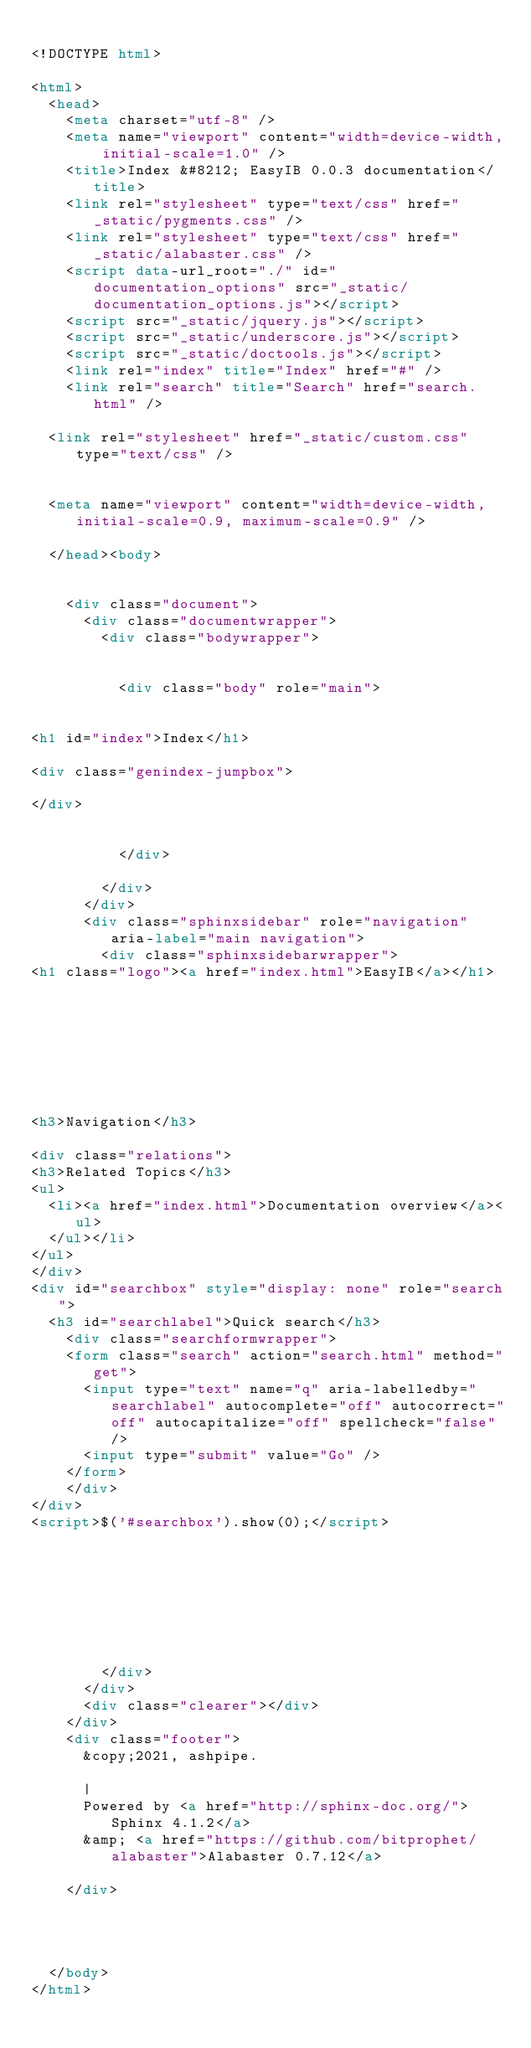<code> <loc_0><loc_0><loc_500><loc_500><_HTML_>
<!DOCTYPE html>

<html>
  <head>
    <meta charset="utf-8" />
    <meta name="viewport" content="width=device-width, initial-scale=1.0" />
    <title>Index &#8212; EasyIB 0.0.3 documentation</title>
    <link rel="stylesheet" type="text/css" href="_static/pygments.css" />
    <link rel="stylesheet" type="text/css" href="_static/alabaster.css" />
    <script data-url_root="./" id="documentation_options" src="_static/documentation_options.js"></script>
    <script src="_static/jquery.js"></script>
    <script src="_static/underscore.js"></script>
    <script src="_static/doctools.js"></script>
    <link rel="index" title="Index" href="#" />
    <link rel="search" title="Search" href="search.html" />
   
  <link rel="stylesheet" href="_static/custom.css" type="text/css" />
  
  
  <meta name="viewport" content="width=device-width, initial-scale=0.9, maximum-scale=0.9" />

  </head><body>
  

    <div class="document">
      <div class="documentwrapper">
        <div class="bodywrapper">
          

          <div class="body" role="main">
            

<h1 id="index">Index</h1>

<div class="genindex-jumpbox">
 
</div>


          </div>
          
        </div>
      </div>
      <div class="sphinxsidebar" role="navigation" aria-label="main navigation">
        <div class="sphinxsidebarwrapper">
<h1 class="logo"><a href="index.html">EasyIB</a></h1>








<h3>Navigation</h3>

<div class="relations">
<h3>Related Topics</h3>
<ul>
  <li><a href="index.html">Documentation overview</a><ul>
  </ul></li>
</ul>
</div>
<div id="searchbox" style="display: none" role="search">
  <h3 id="searchlabel">Quick search</h3>
    <div class="searchformwrapper">
    <form class="search" action="search.html" method="get">
      <input type="text" name="q" aria-labelledby="searchlabel" autocomplete="off" autocorrect="off" autocapitalize="off" spellcheck="false"/>
      <input type="submit" value="Go" />
    </form>
    </div>
</div>
<script>$('#searchbox').show(0);</script>








        </div>
      </div>
      <div class="clearer"></div>
    </div>
    <div class="footer">
      &copy;2021, ashpipe.
      
      |
      Powered by <a href="http://sphinx-doc.org/">Sphinx 4.1.2</a>
      &amp; <a href="https://github.com/bitprophet/alabaster">Alabaster 0.7.12</a>
      
    </div>

    

    
  </body>
</html></code> 